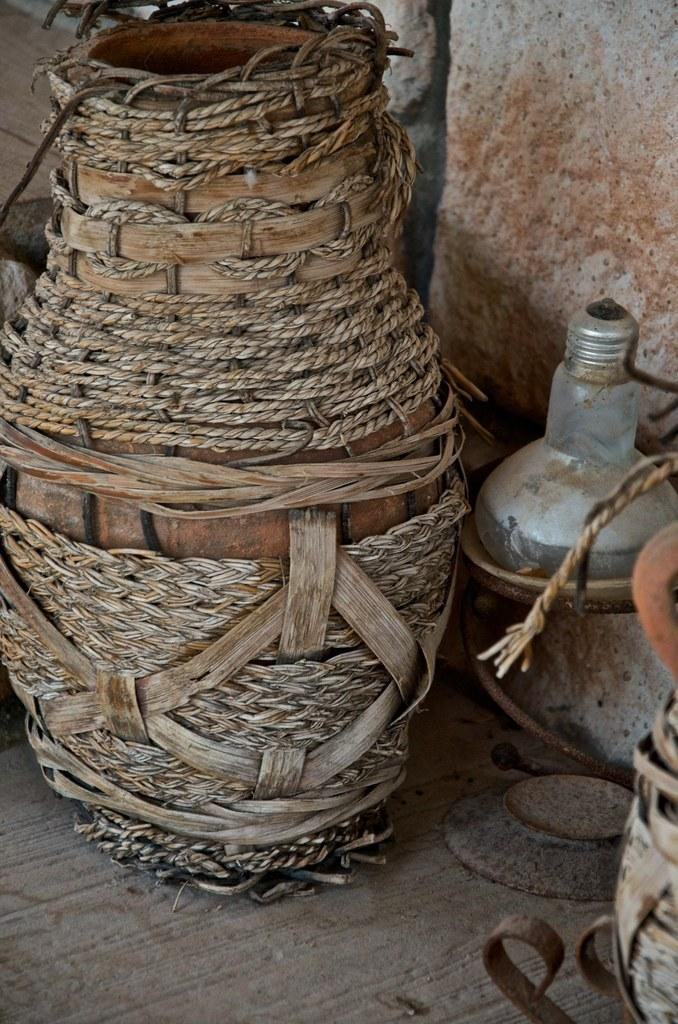What is the main object in the image that is wrapped with thread? There is a pot wrapped with thread in the image. What other objects can be seen in the image? There is a bottle and a plate in the image. What is the surface on which these objects are placed? There are other objects on a surface in the image. How many elbows can be seen in the image? There are no elbows visible in the image. What type of hose is connected to the bottle in the image? There is no hose connected to the bottle in the image. 